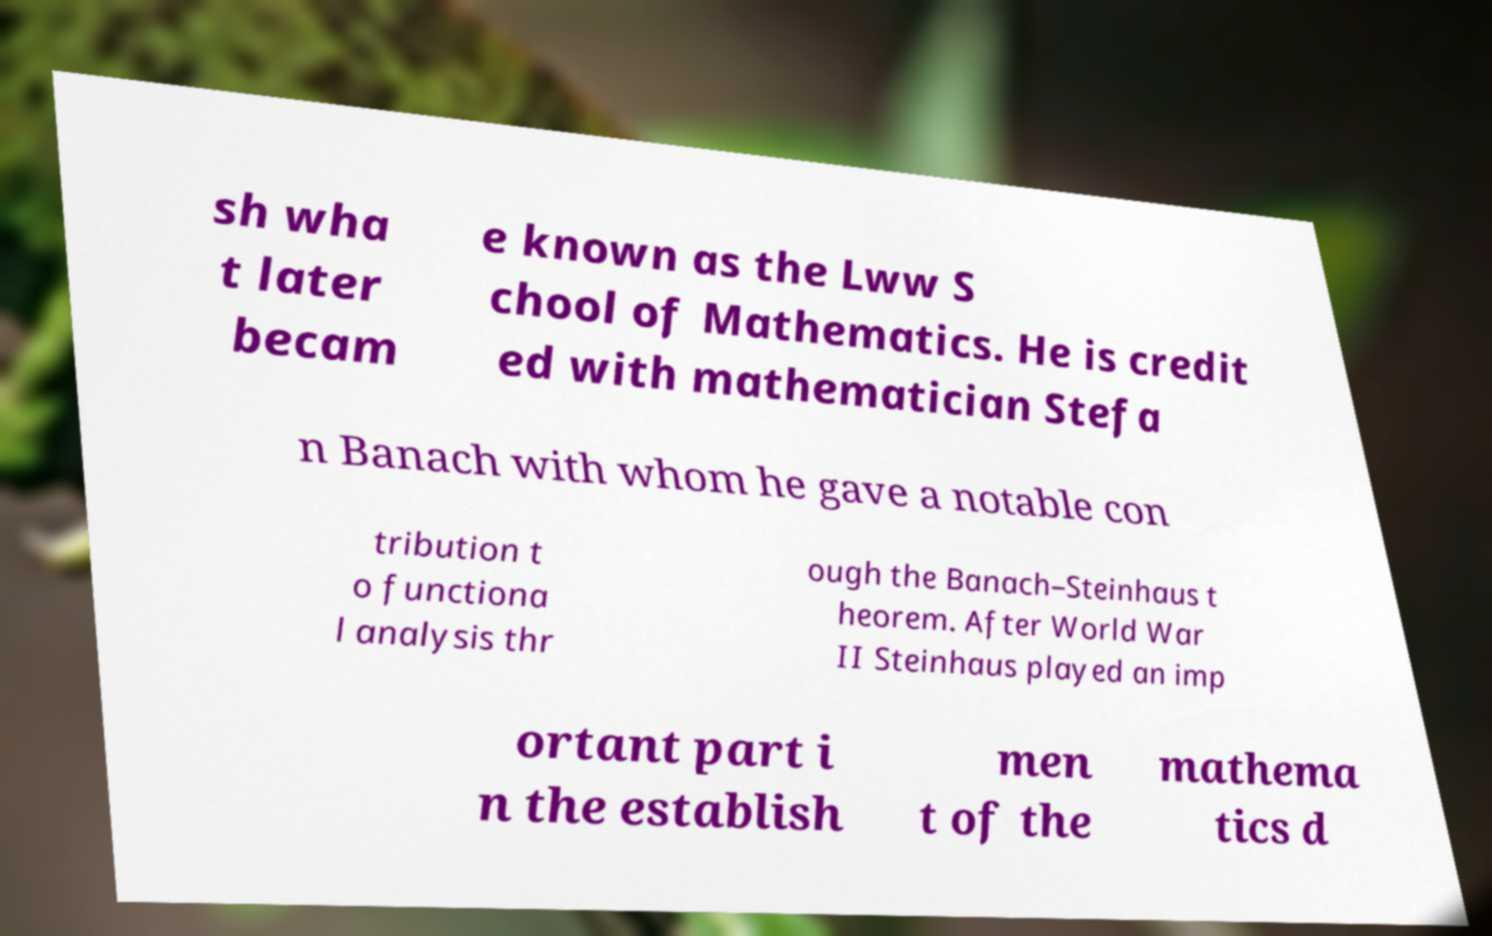Can you read and provide the text displayed in the image?This photo seems to have some interesting text. Can you extract and type it out for me? sh wha t later becam e known as the Lww S chool of Mathematics. He is credit ed with mathematician Stefa n Banach with whom he gave a notable con tribution t o functiona l analysis thr ough the Banach–Steinhaus t heorem. After World War II Steinhaus played an imp ortant part i n the establish men t of the mathema tics d 